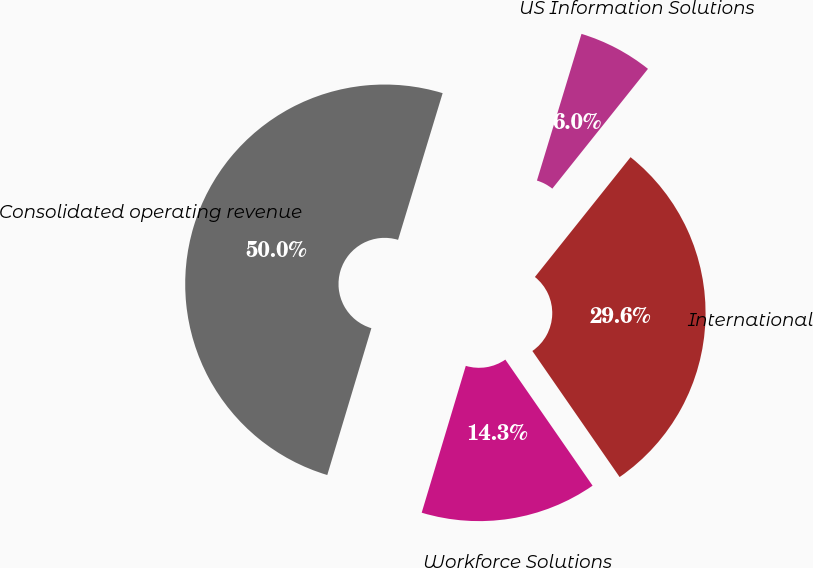Convert chart to OTSL. <chart><loc_0><loc_0><loc_500><loc_500><pie_chart><fcel>US Information Solutions<fcel>International<fcel>Workforce Solutions<fcel>Consolidated operating revenue<nl><fcel>6.03%<fcel>29.64%<fcel>14.28%<fcel>50.05%<nl></chart> 